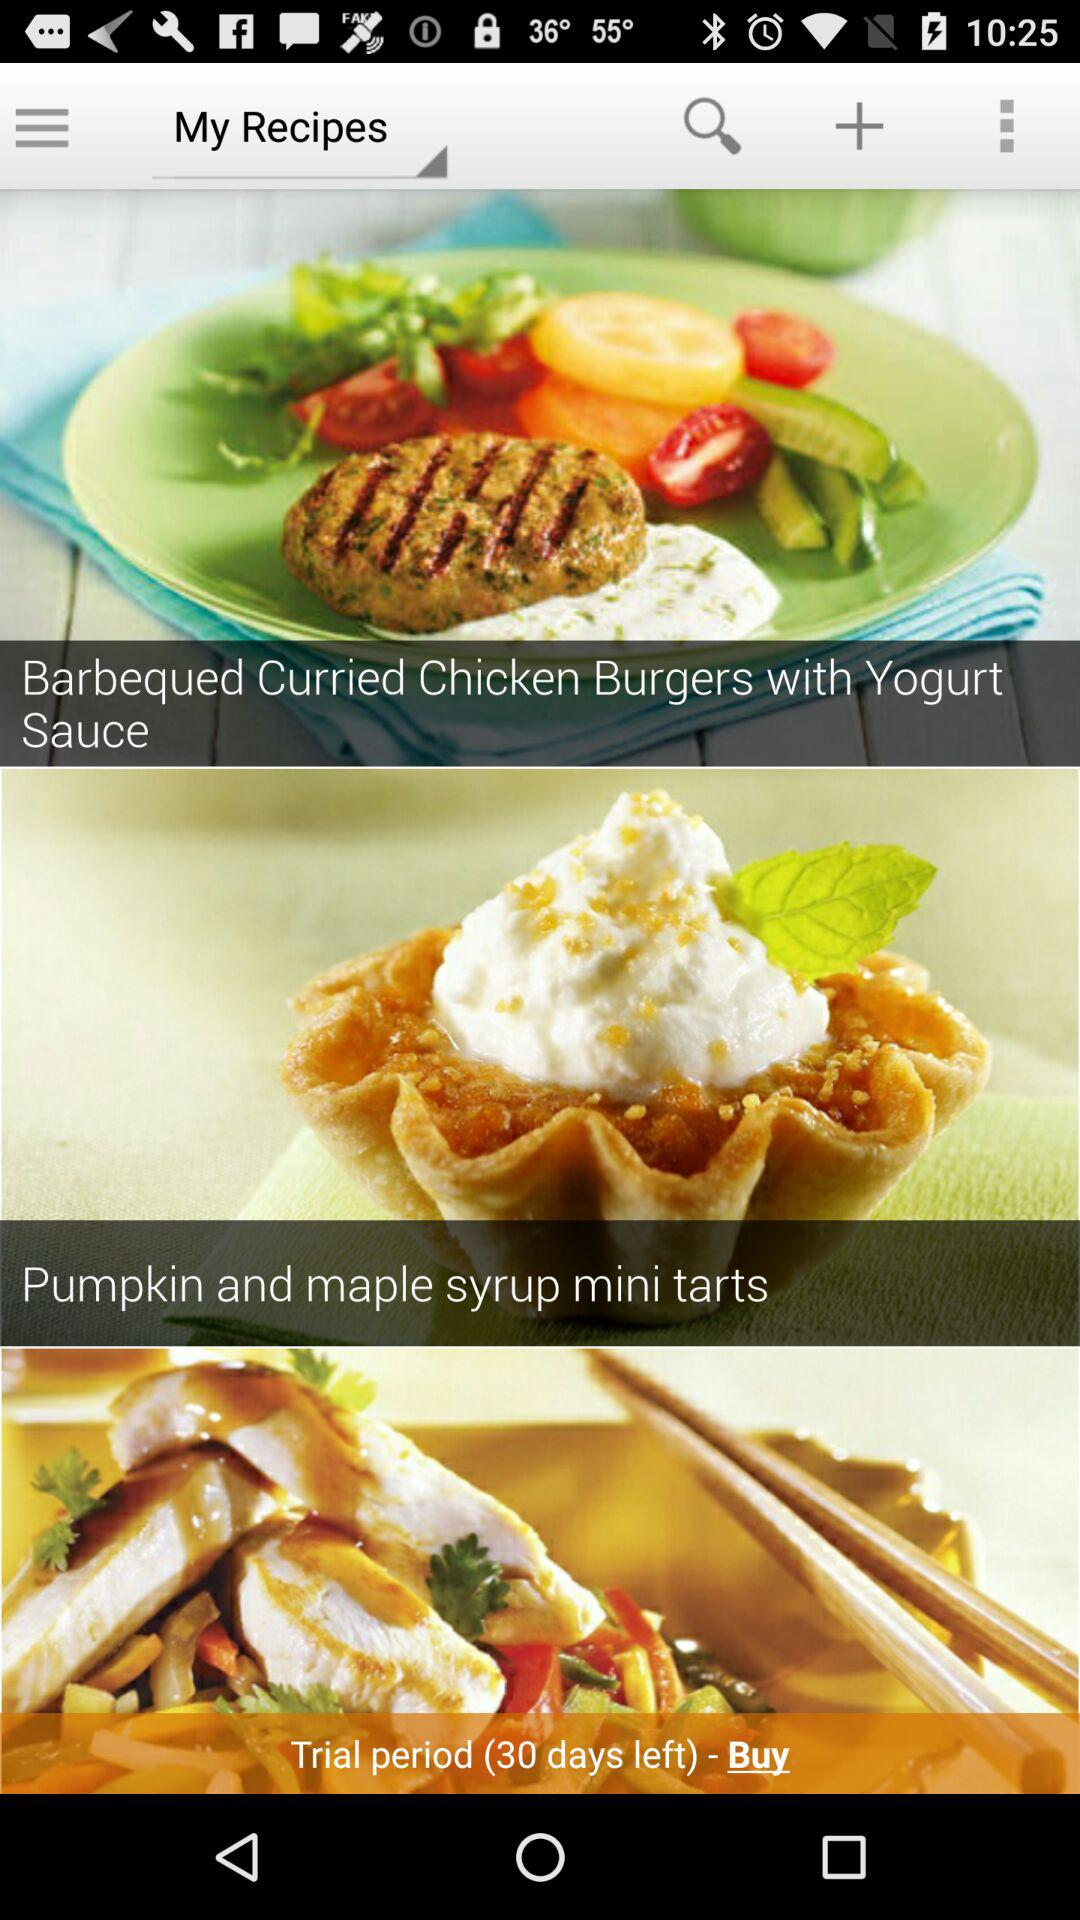How many days are left in the trial period? There are 30 days left in the trial period. 